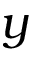Convert formula to latex. <formula><loc_0><loc_0><loc_500><loc_500>y</formula> 